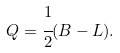Convert formula to latex. <formula><loc_0><loc_0><loc_500><loc_500>Q = \cfrac { 1 } { 2 } ( B - L ) .</formula> 